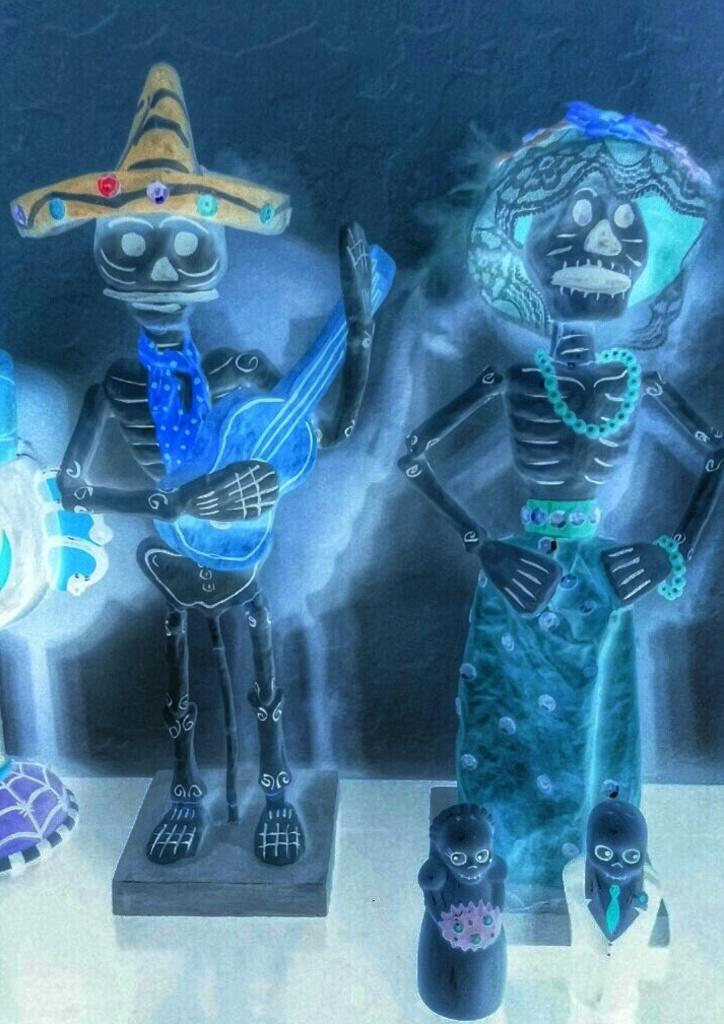What objects can be seen on the surface in the image? There are toys on a surface in the image. Can you describe the background visible in the image? Unfortunately, the provided facts do not give any details about the background. However, we can still discuss the toys on the surface. What type of brick is being used as a tail for the toy in the image? There is no brick or toy with a tail present in the image. 